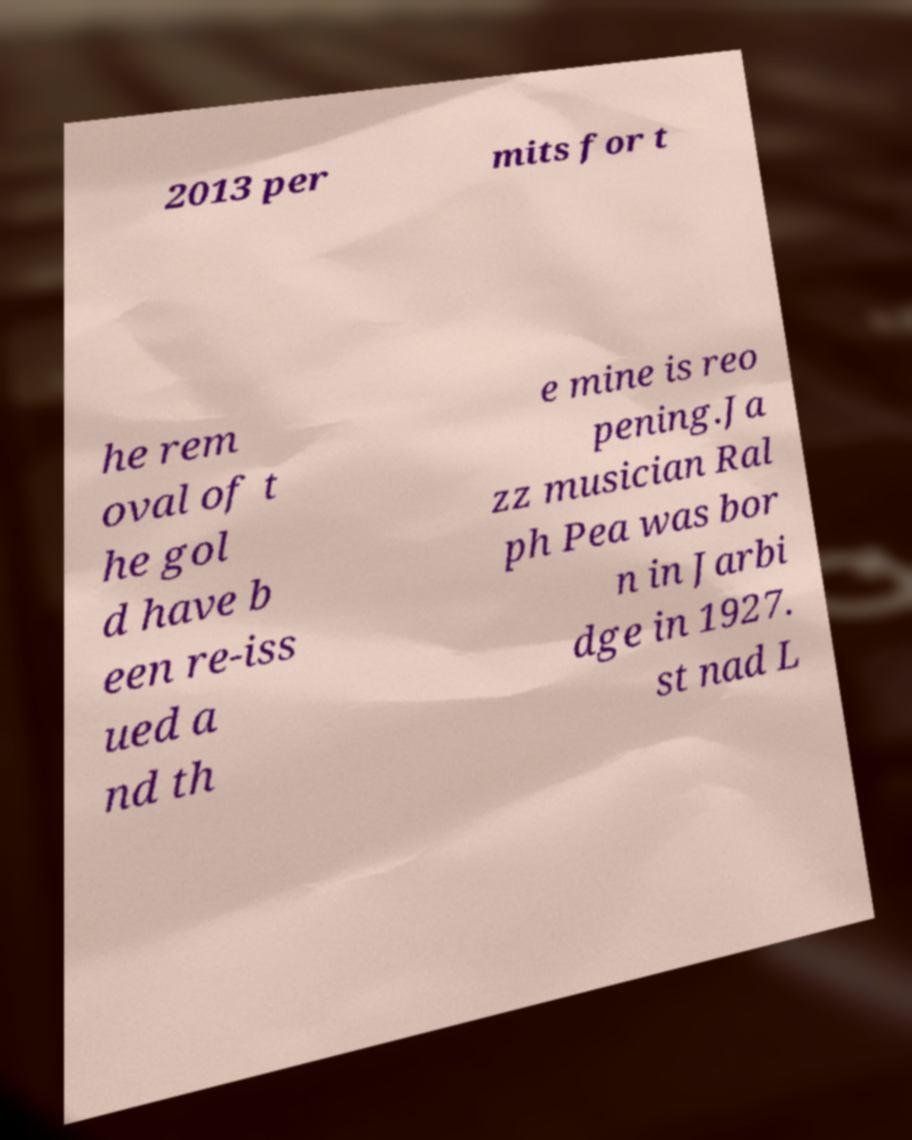There's text embedded in this image that I need extracted. Can you transcribe it verbatim? 2013 per mits for t he rem oval of t he gol d have b een re-iss ued a nd th e mine is reo pening.Ja zz musician Ral ph Pea was bor n in Jarbi dge in 1927. st nad L 